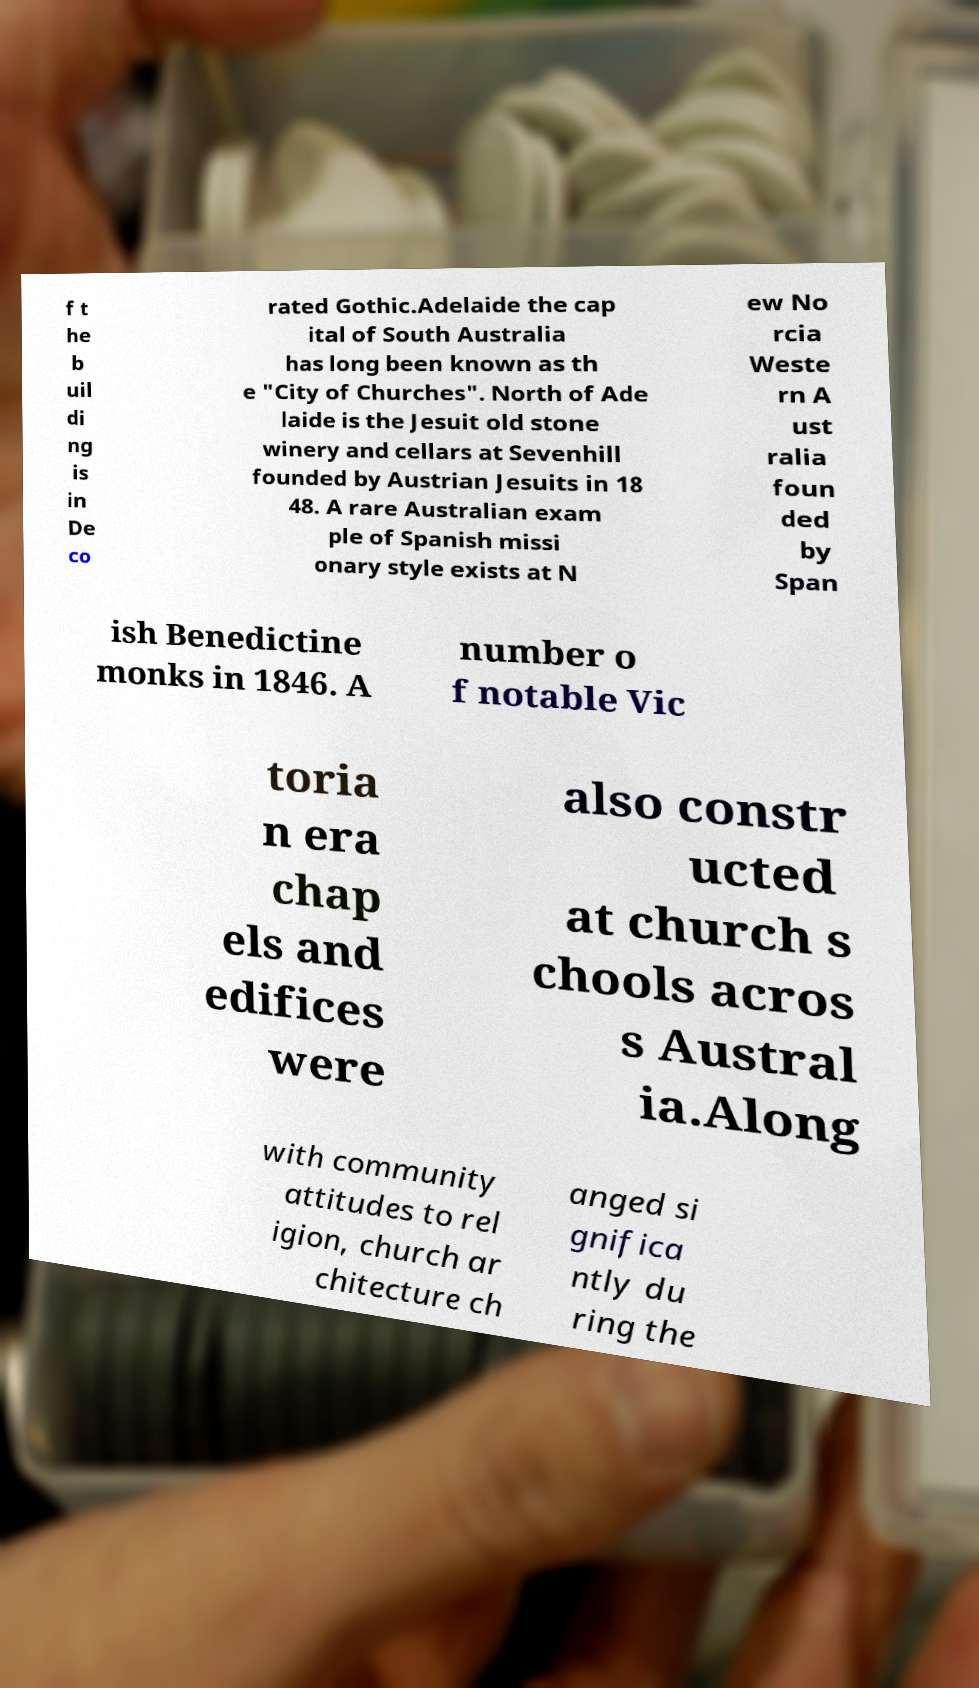Can you accurately transcribe the text from the provided image for me? f t he b uil di ng is in De co rated Gothic.Adelaide the cap ital of South Australia has long been known as th e "City of Churches". North of Ade laide is the Jesuit old stone winery and cellars at Sevenhill founded by Austrian Jesuits in 18 48. A rare Australian exam ple of Spanish missi onary style exists at N ew No rcia Weste rn A ust ralia foun ded by Span ish Benedictine monks in 1846. A number o f notable Vic toria n era chap els and edifices were also constr ucted at church s chools acros s Austral ia.Along with community attitudes to rel igion, church ar chitecture ch anged si gnifica ntly du ring the 